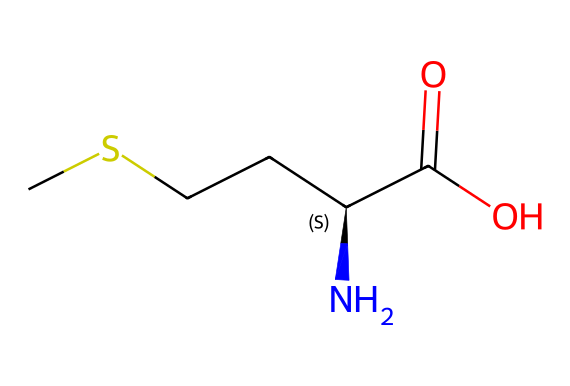How many carbon atoms are in methionine? The SMILES representation shows that the structure contains two carbon chains and identifies a total of four carbon atoms (the two from the aliphatic chain and two from the amino and carboxyl groups).
Answer: four What is the functional group present in methionine? Analyzing the structure, there's a carboxyl group (-COOH) and an amino group (-NH2) present in the chemical makeup, which are typical functional groups found in amino acids.
Answer: carboxyl and amino groups What type of amino acid is methionine? Considering the presence of a sulfur atom in the structure, methionine is classified as a sulfur-containing amino acid, which influences its classification compared to other amino acids.
Answer: sulfur-containing amino acid What is the molecular formula of methionine? By counting the atoms of each element represented in the SMILES, methionine consists of 5 carbon (C), 11 hydrogen (H), 1 nitrogen (N), 2 oxygen (O), and 1 sulfur (S) yielding the molecular formula C5H11NO2S.
Answer: C5H11NO2S Which atom in methionine is responsible for its organosulfur classification? The presence of a sulfur atom (S) in the molecular structure confirms that methionine falls under the category of organosulfur compounds, as this classification is specifically based on the inclusion of sulfur in the compound.
Answer: sulfur 